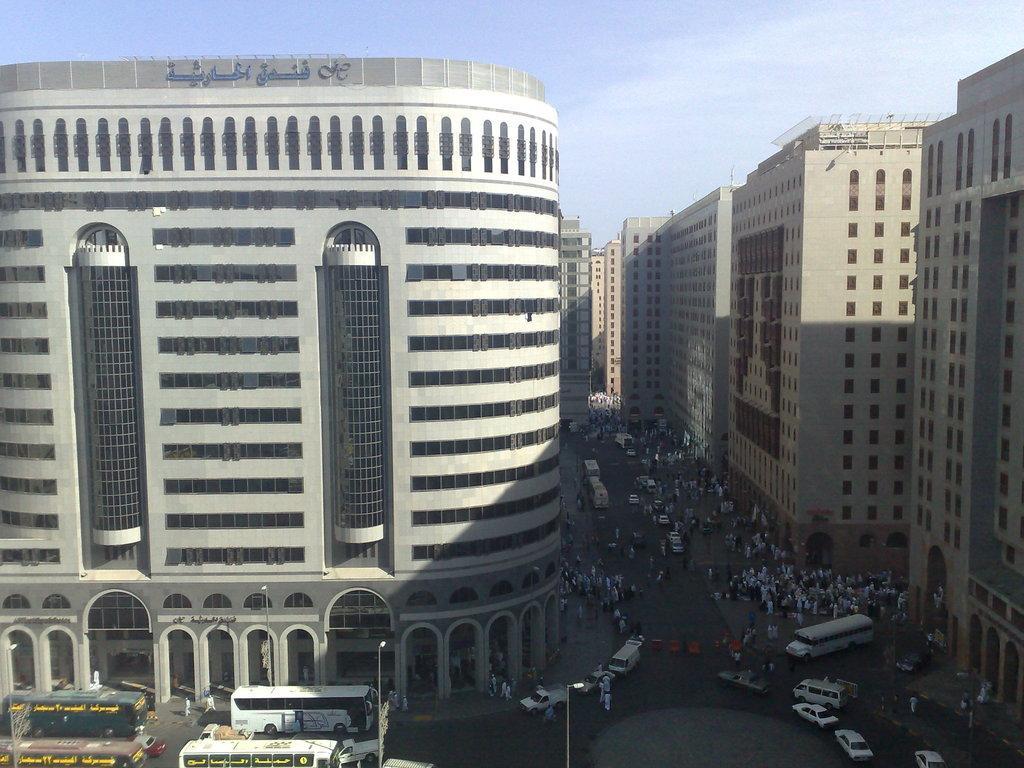Describe this image in one or two sentences. This is the picture of a city. In this image there are buildings. At the bottom there are vehicles and there are poles and there are group of people on the road. At the top there is sky. There is a text on the building. 